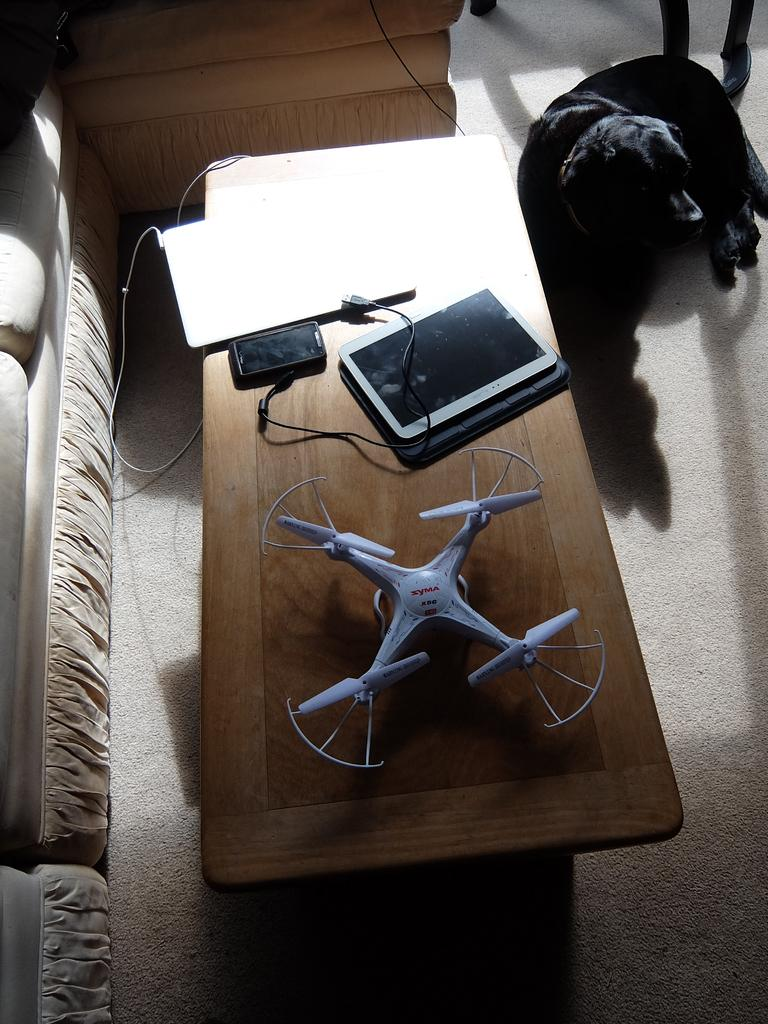What is the main piece of furniture in the image? There is a table in the image. Who or what is on the table? A person (you) is present on the table. What electronic devices can be seen on the table? A mobile phone and a laptop are visible on the table. What else is on the table besides the electronic devices? There is a tab and a cable on the table. What type of animal is in the image? There is a dog in the image. What other piece of furniture is in the image? There is a couch in the image. What part of the room can be seen in the image? The floor is visible in the image. How does the wind affect the laptop on the table? There is no wind present in the image, so it cannot affect the laptop. What specific detail about the dog can be observed in the image? The provided facts do not mention any specific details about the dog, so we cannot answer this question definitively. 